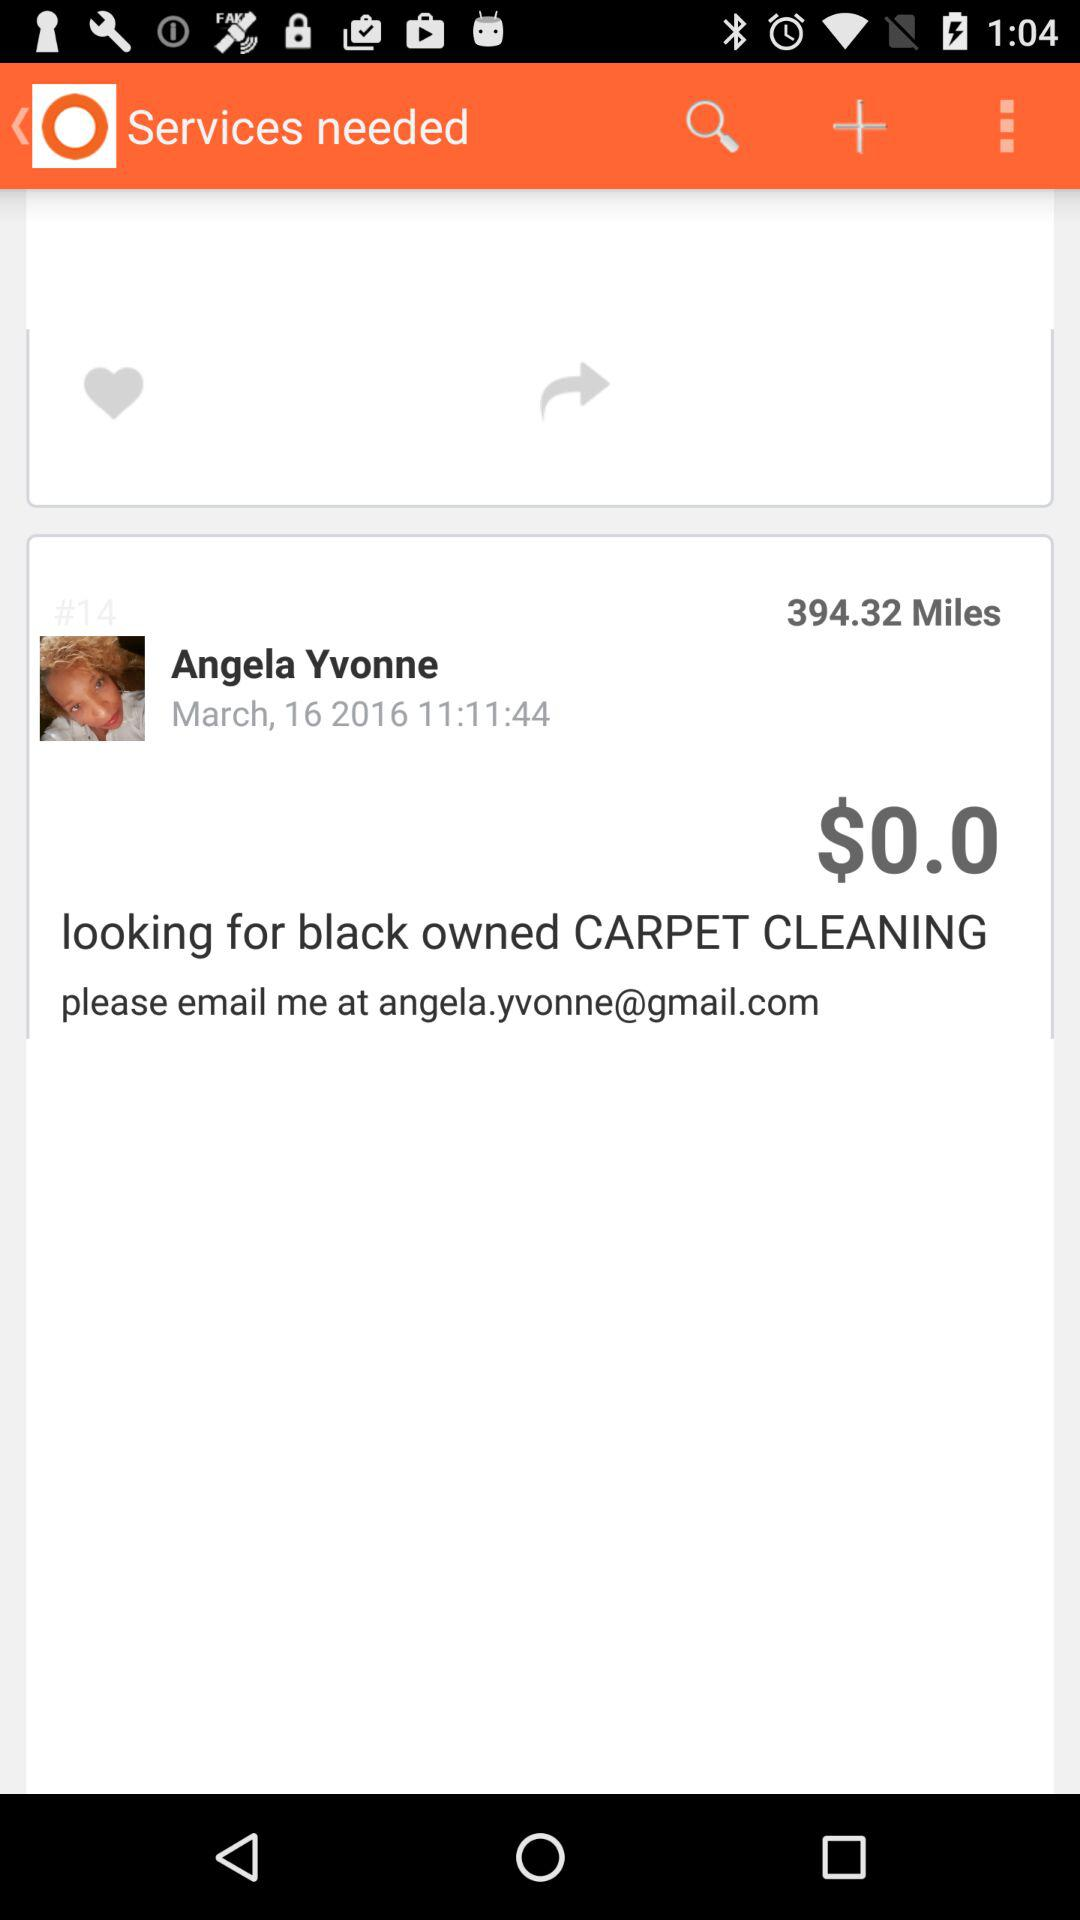What is the mentioned date? The mentioned date is March 16, 2016. 